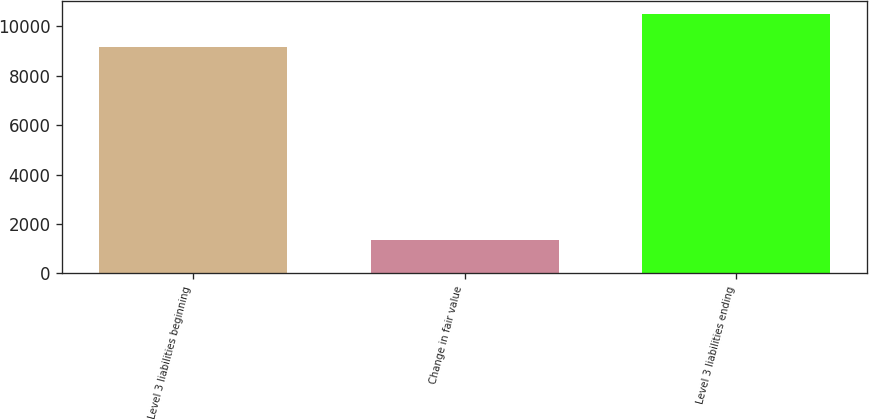Convert chart to OTSL. <chart><loc_0><loc_0><loc_500><loc_500><bar_chart><fcel>Level 3 liabilities beginning<fcel>Change in fair value<fcel>Level 3 liabilities ending<nl><fcel>9153<fcel>1337<fcel>10490<nl></chart> 